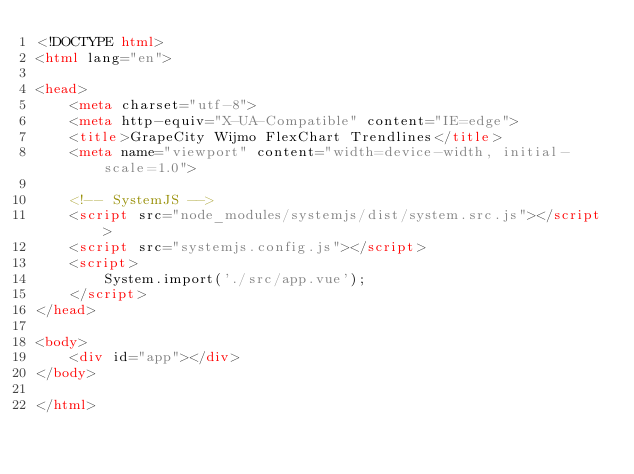<code> <loc_0><loc_0><loc_500><loc_500><_HTML_><!DOCTYPE html>
<html lang="en">

<head>
    <meta charset="utf-8">
    <meta http-equiv="X-UA-Compatible" content="IE=edge">
    <title>GrapeCity Wijmo FlexChart Trendlines</title>
    <meta name="viewport" content="width=device-width, initial-scale=1.0">

    <!-- SystemJS -->
    <script src="node_modules/systemjs/dist/system.src.js"></script>
    <script src="systemjs.config.js"></script>
    <script>
        System.import('./src/app.vue');
    </script>
</head>

<body>
    <div id="app"></div>
</body>

</html></code> 